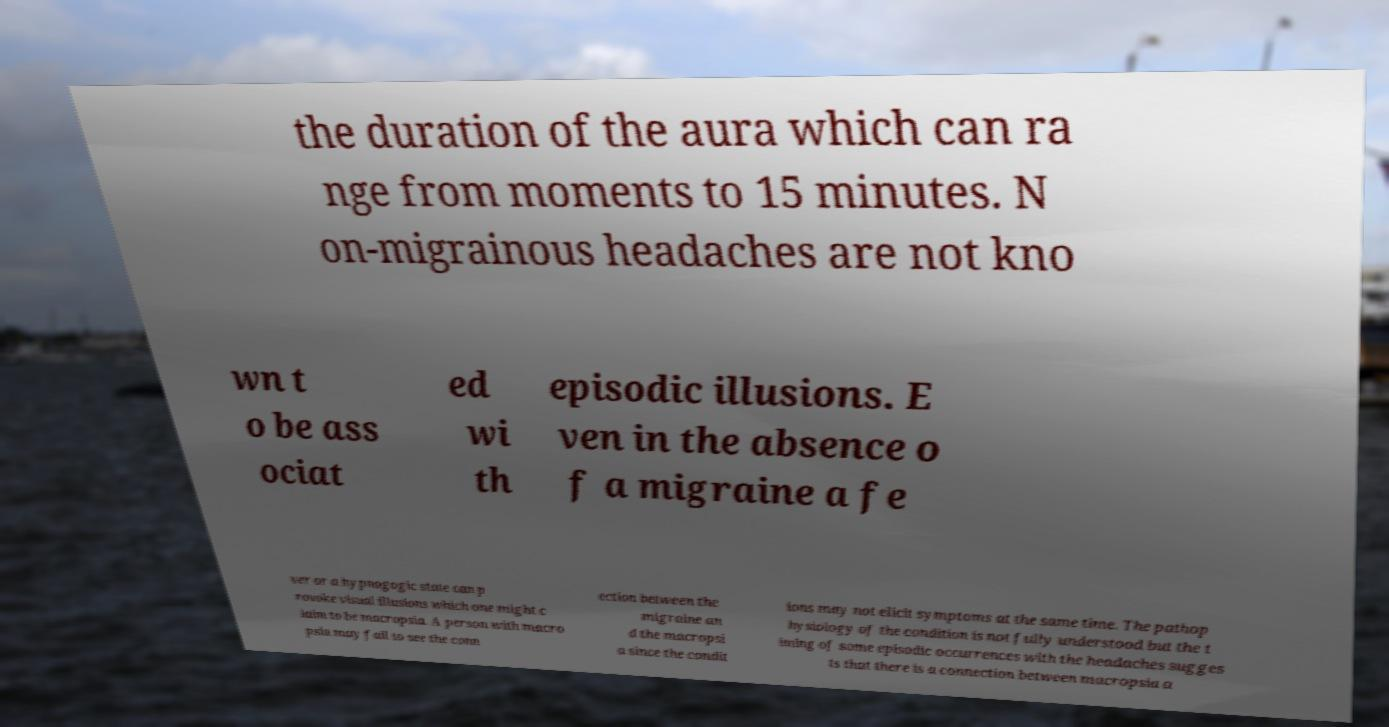Please identify and transcribe the text found in this image. the duration of the aura which can ra nge from moments to 15 minutes. N on-migrainous headaches are not kno wn t o be ass ociat ed wi th episodic illusions. E ven in the absence o f a migraine a fe ver or a hypnogogic state can p rovoke visual illusions which one might c laim to be macropsia. A person with macro psia may fail to see the conn ection between the migraine an d the macropsi a since the condit ions may not elicit symptoms at the same time. The pathop hysiology of the condition is not fully understood but the t iming of some episodic occurrences with the headaches sugges ts that there is a connection between macropsia a 